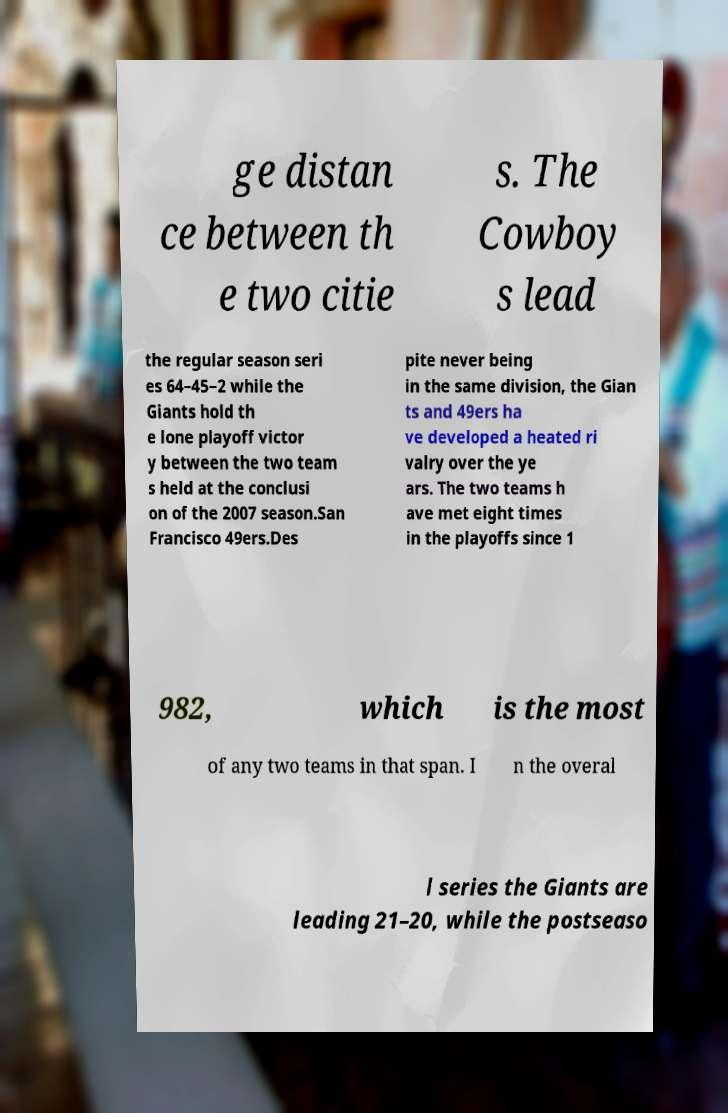For documentation purposes, I need the text within this image transcribed. Could you provide that? ge distan ce between th e two citie s. The Cowboy s lead the regular season seri es 64–45–2 while the Giants hold th e lone playoff victor y between the two team s held at the conclusi on of the 2007 season.San Francisco 49ers.Des pite never being in the same division, the Gian ts and 49ers ha ve developed a heated ri valry over the ye ars. The two teams h ave met eight times in the playoffs since 1 982, which is the most of any two teams in that span. I n the overal l series the Giants are leading 21–20, while the postseaso 